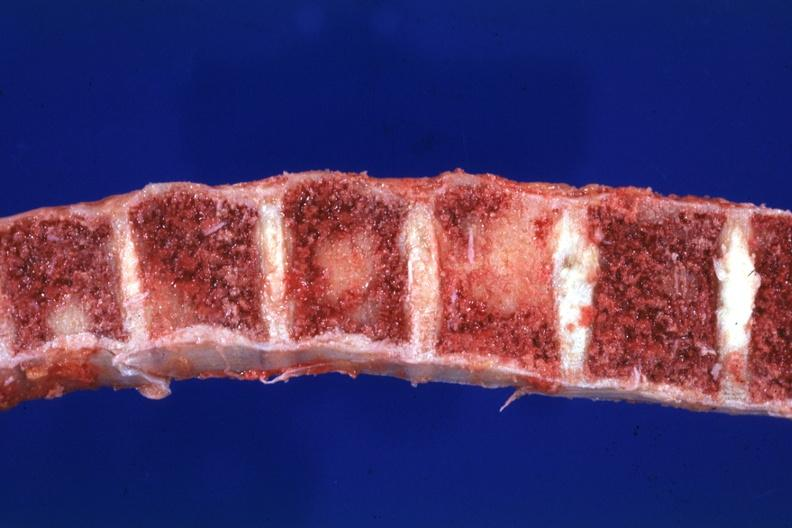what does this image show?
Answer the question using a single word or phrase. Close-up view typical lesions 